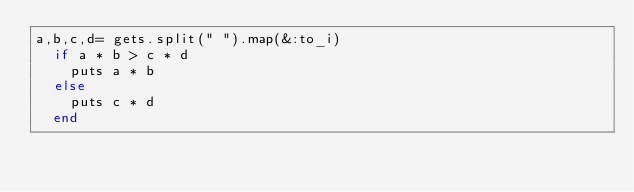<code> <loc_0><loc_0><loc_500><loc_500><_Ruby_>a,b,c,d= gets.split(" ").map(&:to_i)
  if a * b > c * d
    puts a * b
  else
    puts c * d
  end</code> 